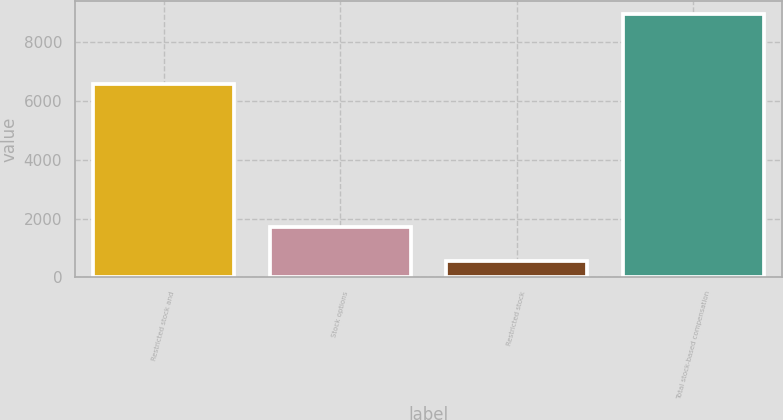Convert chart. <chart><loc_0><loc_0><loc_500><loc_500><bar_chart><fcel>Restricted stock and<fcel>Stock options<fcel>Restricted stock<fcel>Total stock-based compensation<nl><fcel>6588<fcel>1728<fcel>570<fcel>8969<nl></chart> 